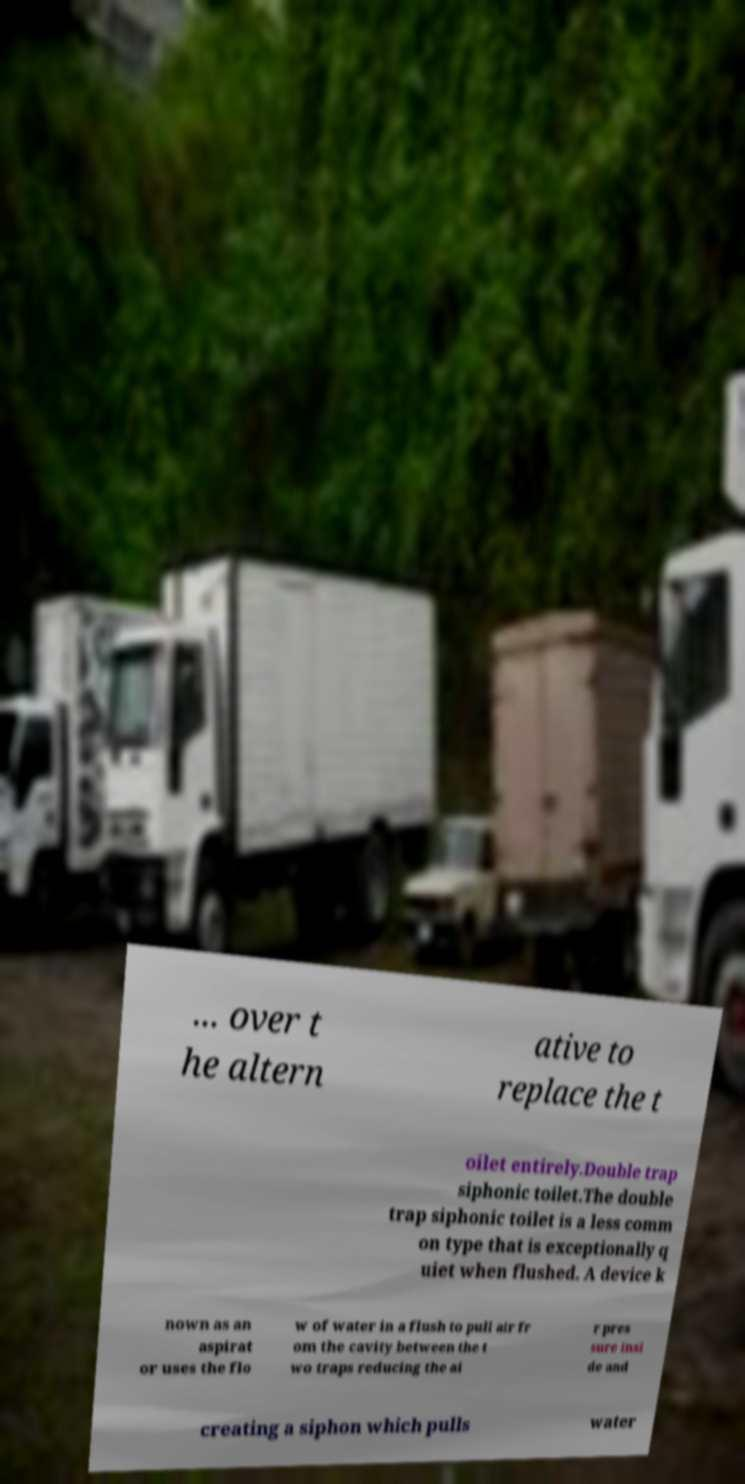What messages or text are displayed in this image? I need them in a readable, typed format. ... over t he altern ative to replace the t oilet entirely.Double trap siphonic toilet.The double trap siphonic toilet is a less comm on type that is exceptionally q uiet when flushed. A device k nown as an aspirat or uses the flo w of water in a flush to pull air fr om the cavity between the t wo traps reducing the ai r pres sure insi de and creating a siphon which pulls water 